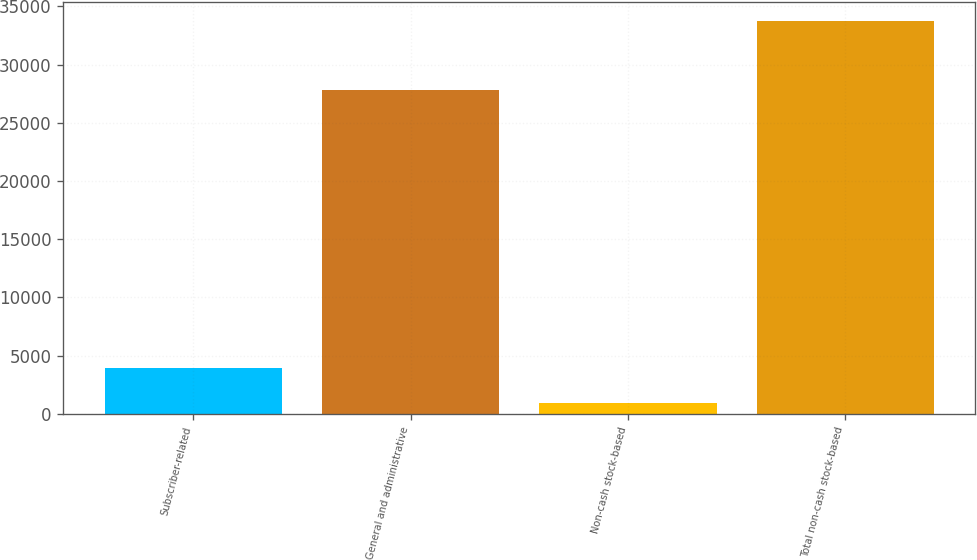Convert chart. <chart><loc_0><loc_0><loc_500><loc_500><bar_chart><fcel>Subscriber-related<fcel>General and administrative<fcel>Non-cash stock-based<fcel>Total non-cash stock-based<nl><fcel>3898<fcel>27783<fcel>925<fcel>33729<nl></chart> 